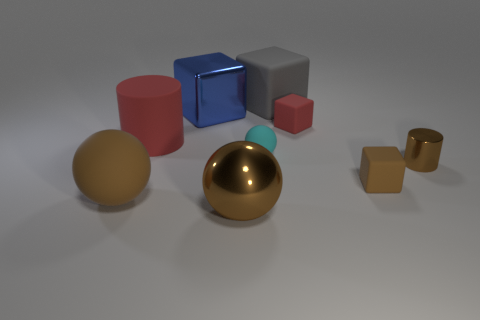Which object stands out the most in this composition? The object that stands out the most is the large gold matte sphere due to its size, central placement, and distinctive color that contrasts markedly with the muted colors of the other objects and the neutral grey background.  Is there a pattern in how the objects are arranged? While there is no strict pattern, the objects seem to be arranged to demonstrate a sense of balance and contrast in size, color, and texture. The larger items are centered and surrounded by smaller ones, providing a pleasing aesthetic arrangement that guides the viewer's eye through the composition. 